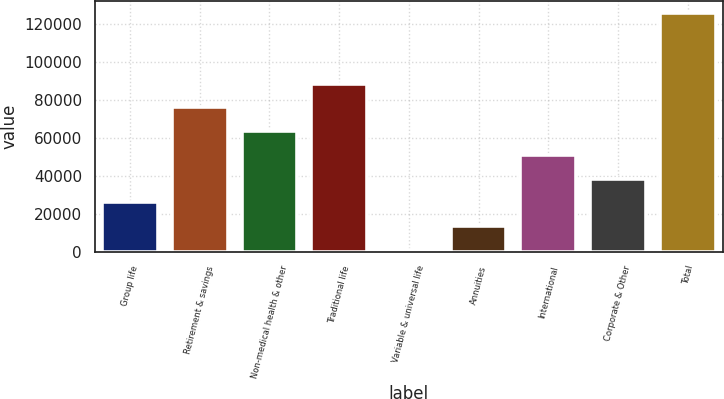Convert chart. <chart><loc_0><loc_0><loc_500><loc_500><bar_chart><fcel>Group life<fcel>Retirement & savings<fcel>Non-medical health & other<fcel>Traditional life<fcel>Variable & universal life<fcel>Annuities<fcel>International<fcel>Corporate & Other<fcel>Total<nl><fcel>25962.4<fcel>75989.2<fcel>63482.5<fcel>88495.9<fcel>949<fcel>13455.7<fcel>50975.8<fcel>38469.1<fcel>126016<nl></chart> 